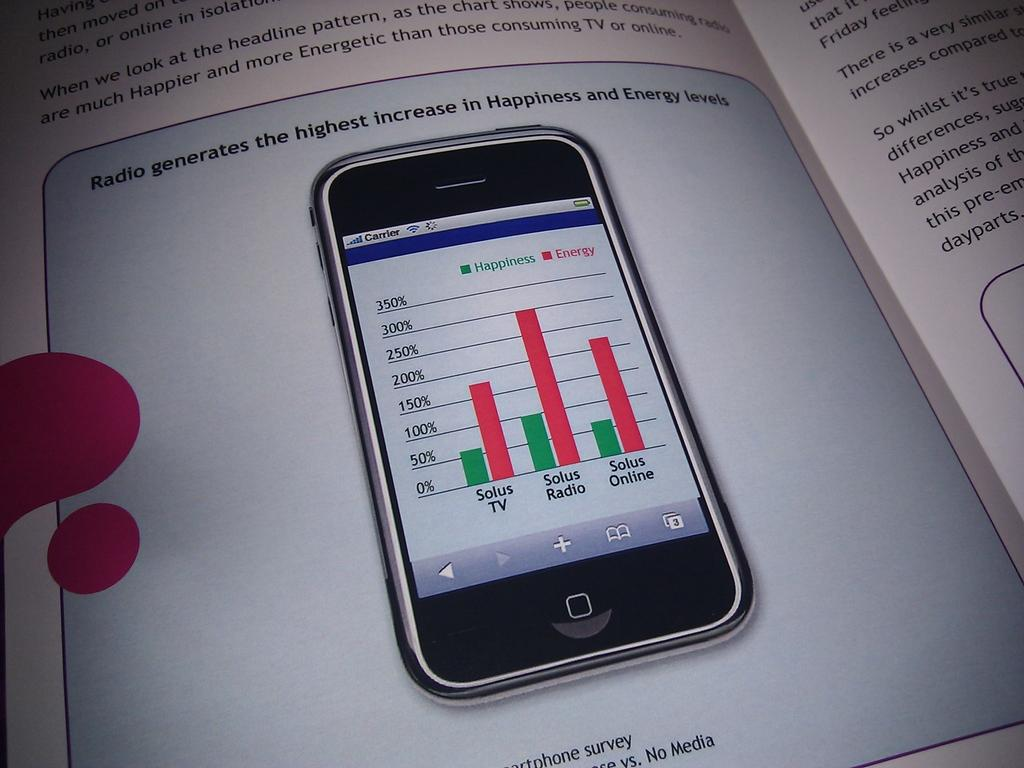<image>
Provide a brief description of the given image. A graph that shows that radio generates the highest increase in happiness and energy levels. 